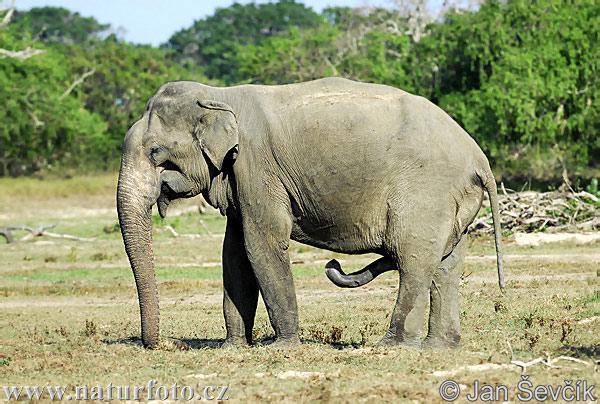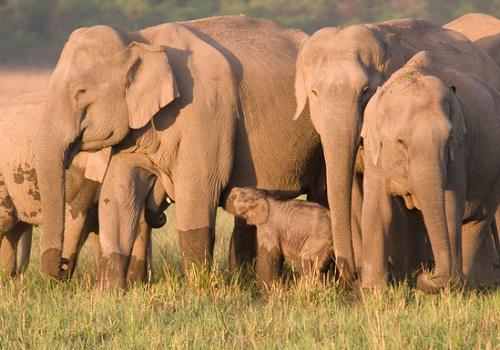The first image is the image on the left, the second image is the image on the right. Considering the images on both sides, is "Both images contain an elephant with tusks." valid? Answer yes or no. No. The first image is the image on the left, the second image is the image on the right. For the images shown, is this caption "There are two elephants fully visible in the picture on the right" true? Answer yes or no. No. 